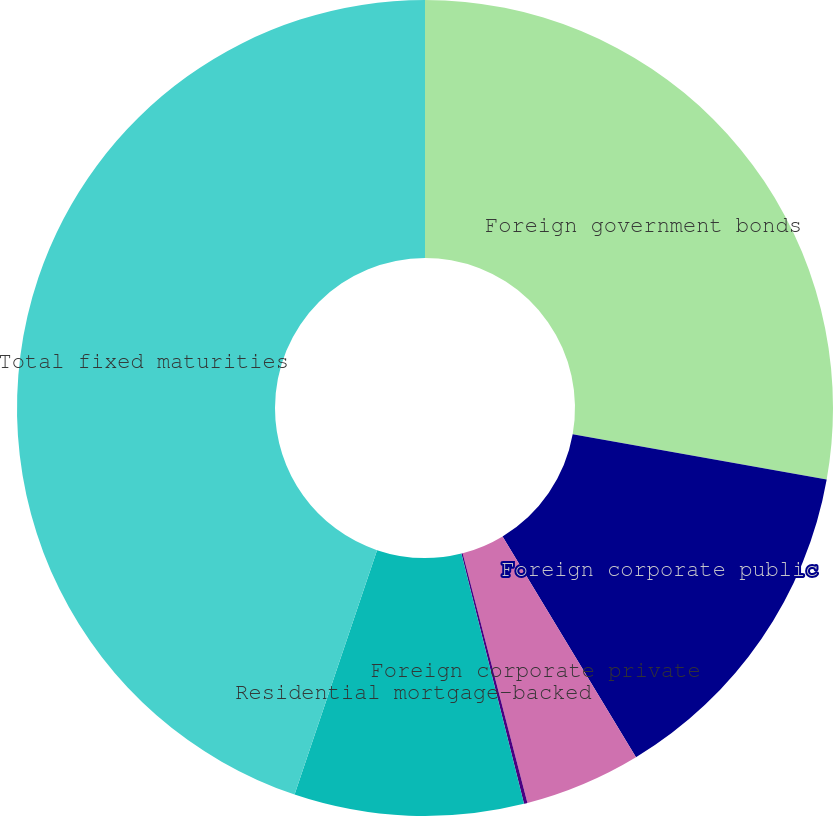<chart> <loc_0><loc_0><loc_500><loc_500><pie_chart><fcel>Foreign government bonds<fcel>Foreign corporate public<fcel>Foreign corporate private<fcel>Commercial mortgage-backed<fcel>Residential mortgage-backed<fcel>Total fixed maturities<nl><fcel>27.8%<fcel>13.55%<fcel>4.61%<fcel>0.14%<fcel>9.08%<fcel>44.82%<nl></chart> 